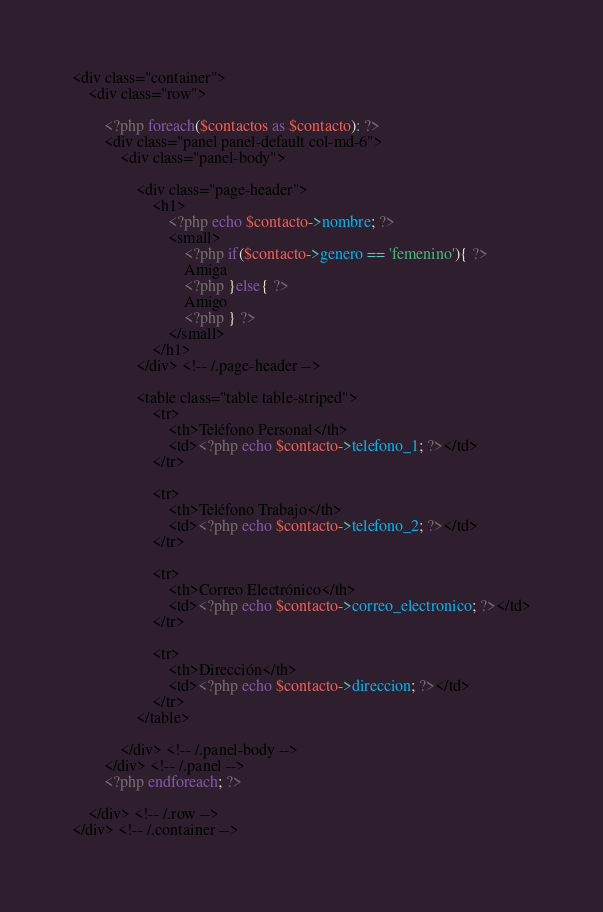Convert code to text. <code><loc_0><loc_0><loc_500><loc_500><_PHP_><div class="container">
    <div class="row">

        <?php foreach($contactos as $contacto): ?>
        <div class="panel panel-default col-md-6">
            <div class="panel-body">

                <div class="page-header">
                    <h1>
                        <?php echo $contacto->nombre; ?>
                        <small>
                            <?php if($contacto->genero == 'femenino'){ ?>
                            Amiga
                            <?php }else{ ?>
                            Amigo
                            <?php } ?>
                        </small>
                    </h1>
                </div> <!-- /.page-header -->

                <table class="table table-striped">
                    <tr>
                        <th>Teléfono Personal</th>
                        <td><?php echo $contacto->telefono_1; ?></td>
                    </tr>

                    <tr>
                        <th>Teléfono Trabajo</th>
                        <td><?php echo $contacto->telefono_2; ?></td>
                    </tr>

                    <tr>
                        <th>Correo Electrónico</th>
                        <td><?php echo $contacto->correo_electronico; ?></td>
                    </tr>

                    <tr>
                        <th>Dirección</th>
                        <td><?php echo $contacto->direccion; ?></td>
                    </tr>
                </table>

            </div> <!-- /.panel-body -->
        </div> <!-- /.panel -->
        <?php endforeach; ?>

    </div> <!-- /.row -->
</div> <!-- /.container -->
</code> 